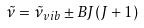Convert formula to latex. <formula><loc_0><loc_0><loc_500><loc_500>\tilde { \nu } = \tilde { \nu } _ { v i b } \pm B J ( J + 1 )</formula> 